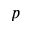Convert formula to latex. <formula><loc_0><loc_0><loc_500><loc_500>p</formula> 